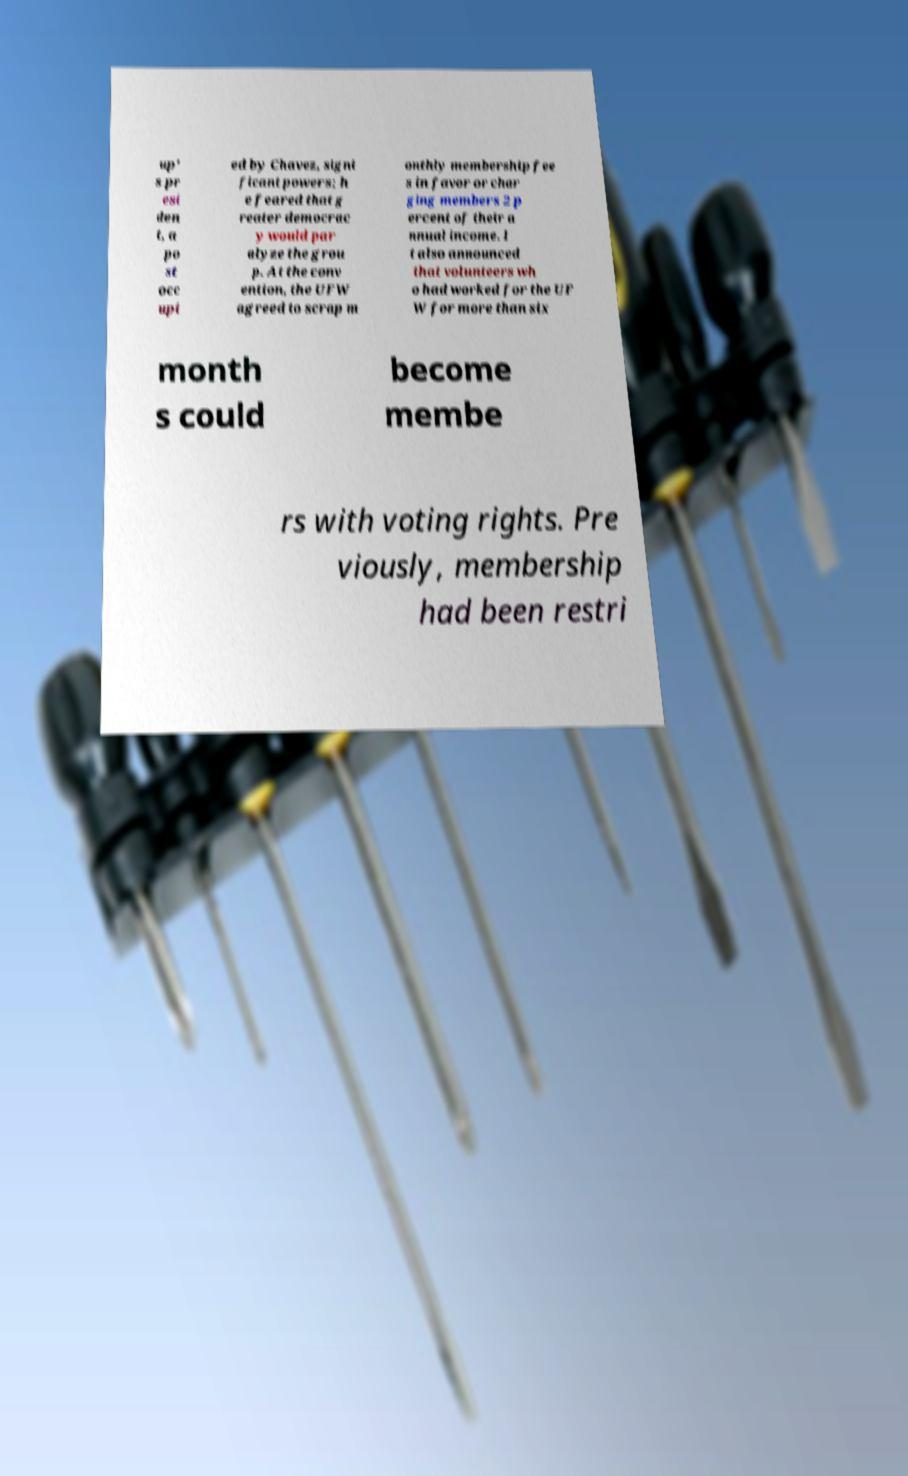Could you extract and type out the text from this image? up' s pr esi den t, a po st occ upi ed by Chavez, signi ficant powers; h e feared that g reater democrac y would par alyze the grou p. At the conv ention, the UFW agreed to scrap m onthly membership fee s in favor or char ging members 2 p ercent of their a nnual income. I t also announced that volunteers wh o had worked for the UF W for more than six month s could become membe rs with voting rights. Pre viously, membership had been restri 